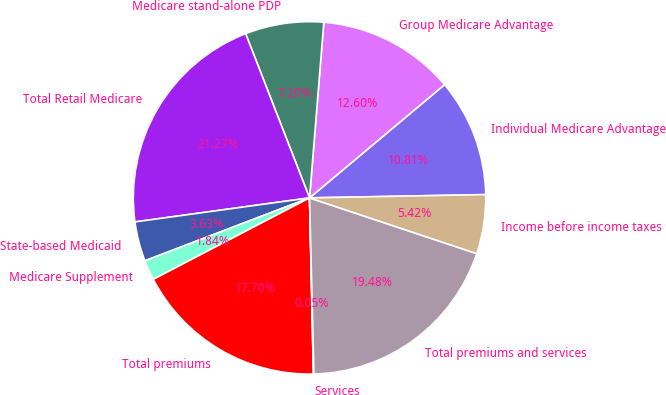Convert chart. <chart><loc_0><loc_0><loc_500><loc_500><pie_chart><fcel>Individual Medicare Advantage<fcel>Group Medicare Advantage<fcel>Medicare stand-alone PDP<fcel>Total Retail Medicare<fcel>State-based Medicaid<fcel>Medicare Supplement<fcel>Total premiums<fcel>Services<fcel>Total premiums and services<fcel>Income before income taxes<nl><fcel>10.81%<fcel>12.6%<fcel>7.2%<fcel>21.27%<fcel>3.63%<fcel>1.84%<fcel>17.7%<fcel>0.05%<fcel>19.48%<fcel>5.42%<nl></chart> 